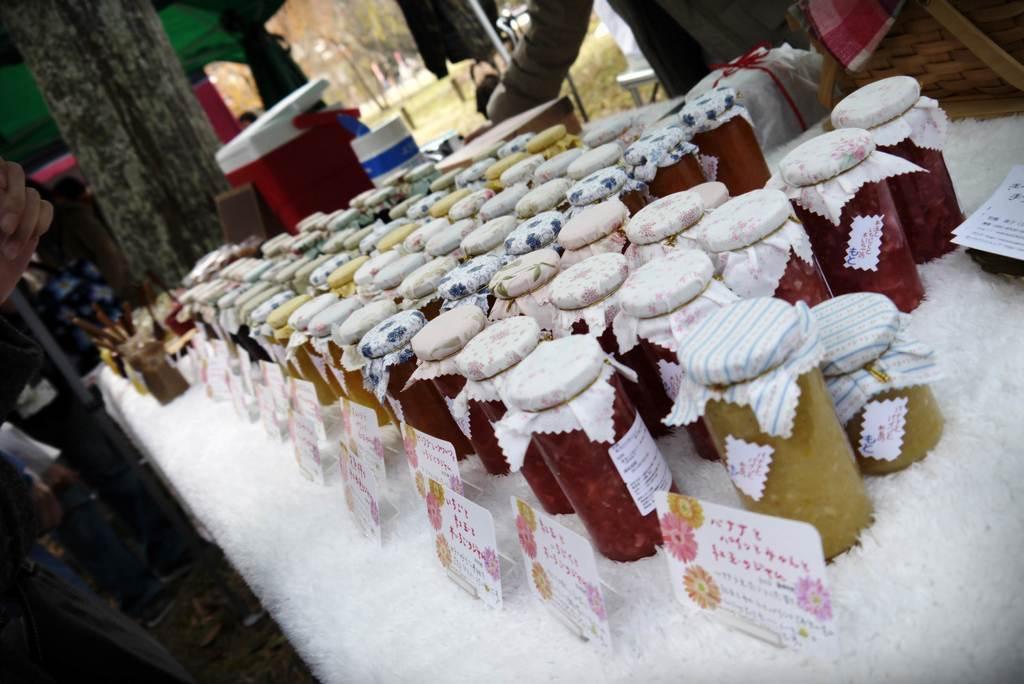Please provide a concise description of this image. This image consists of jars which are kept on the table along with the boards. And we can see a white cloth on the table. In the background, there are boxes and a person standing. At the bottom, there is a floor. 